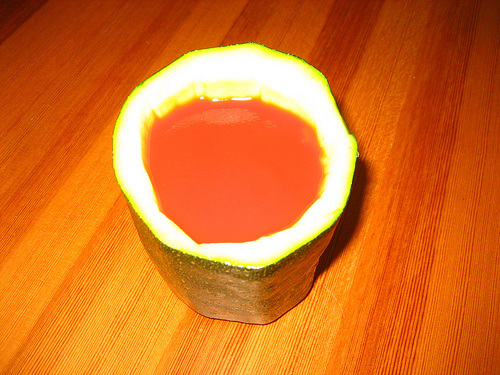<image>
Can you confirm if the juice is in the cup? Yes. The juice is contained within or inside the cup, showing a containment relationship. 